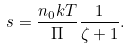<formula> <loc_0><loc_0><loc_500><loc_500>s = \frac { n _ { 0 } k T } { \Pi } \frac { 1 } { \zeta + 1 } .</formula> 